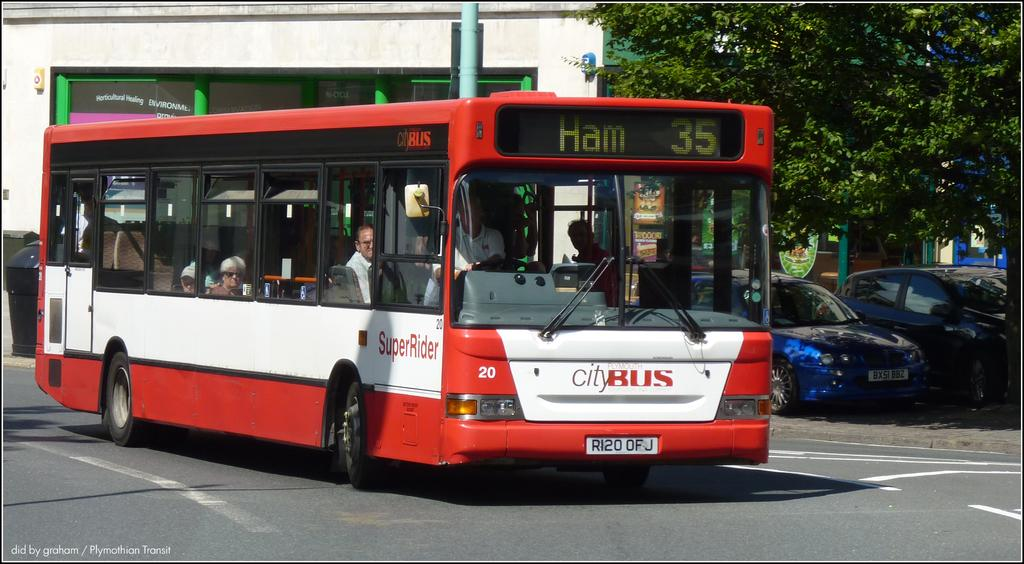What is the main subject of the image? The main subject of the image is a bus. Can you describe the interior of the bus? There are people inside the bus. What else can be seen on the right side of the image? There are two cars on the right side of the image. What is visible in the background of the image? There is a tree and a building in the background of the image. What type of cloud can be seen forming in the image? There is no cloud present in the image; it features a bus, people, cars, a tree, and a building. Can you describe the bird that is perched on the bus in the image? There is no bird present in the image; it only features a bus, people, cars, a tree, and a building. 